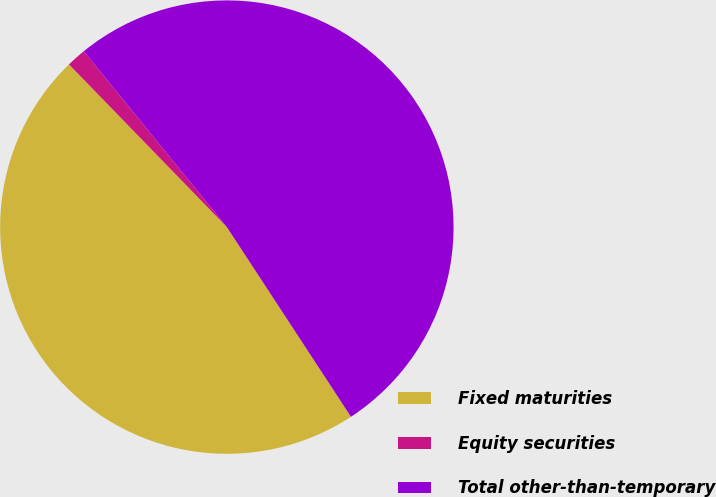<chart> <loc_0><loc_0><loc_500><loc_500><pie_chart><fcel>Fixed maturities<fcel>Equity securities<fcel>Total other-than-temporary<nl><fcel>46.96%<fcel>1.39%<fcel>51.65%<nl></chart> 